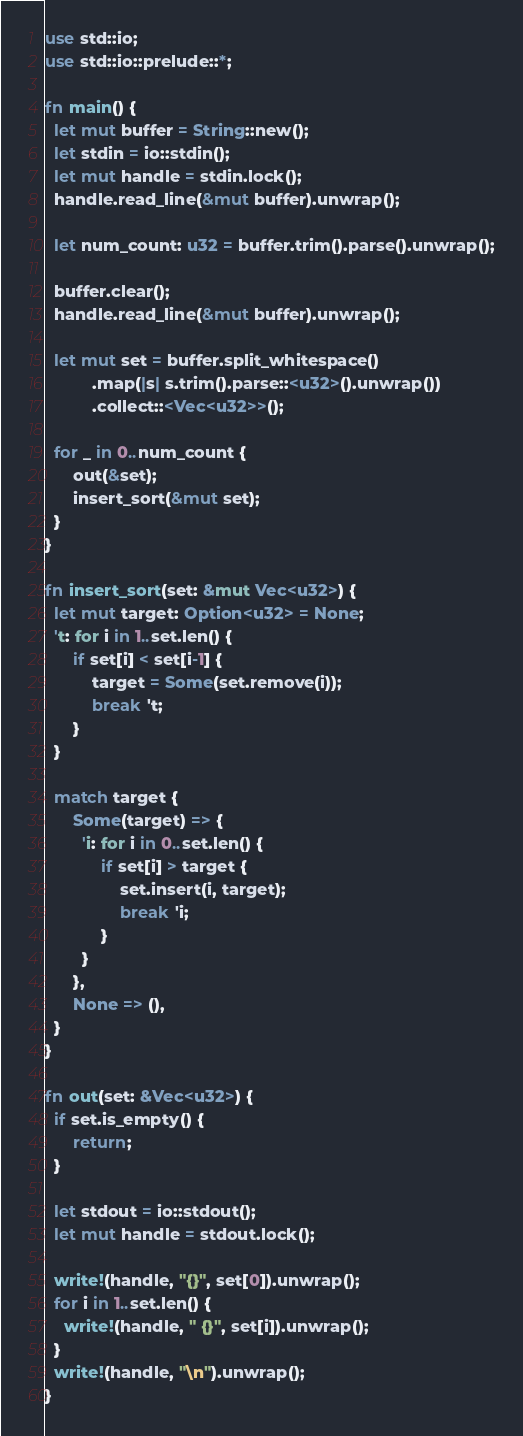Convert code to text. <code><loc_0><loc_0><loc_500><loc_500><_Rust_>use std::io;
use std::io::prelude::*;

fn main() {
  let mut buffer = String::new();
  let stdin = io::stdin();
  let mut handle = stdin.lock();
  handle.read_line(&mut buffer).unwrap();

  let num_count: u32 = buffer.trim().parse().unwrap();

  buffer.clear();
  handle.read_line(&mut buffer).unwrap();

  let mut set = buffer.split_whitespace()
          .map(|s| s.trim().parse::<u32>().unwrap())
          .collect::<Vec<u32>>();

  for _ in 0..num_count {
      out(&set);
      insert_sort(&mut set);
  }
}

fn insert_sort(set: &mut Vec<u32>) {
  let mut target: Option<u32> = None;
  't: for i in 1..set.len() {
      if set[i] < set[i-1] {
          target = Some(set.remove(i));
          break 't;
      }
  }

  match target {
      Some(target) => {
        'i: for i in 0..set.len() {
            if set[i] > target {
                set.insert(i, target);
                break 'i;
            }
        }
      },
      None => (),
  }
}

fn out(set: &Vec<u32>) {
  if set.is_empty() {
      return;
  }

  let stdout = io::stdout();
  let mut handle = stdout.lock();

  write!(handle, "{}", set[0]).unwrap();
  for i in 1..set.len() {
    write!(handle, " {}", set[i]).unwrap();
  }
  write!(handle, "\n").unwrap();
}</code> 